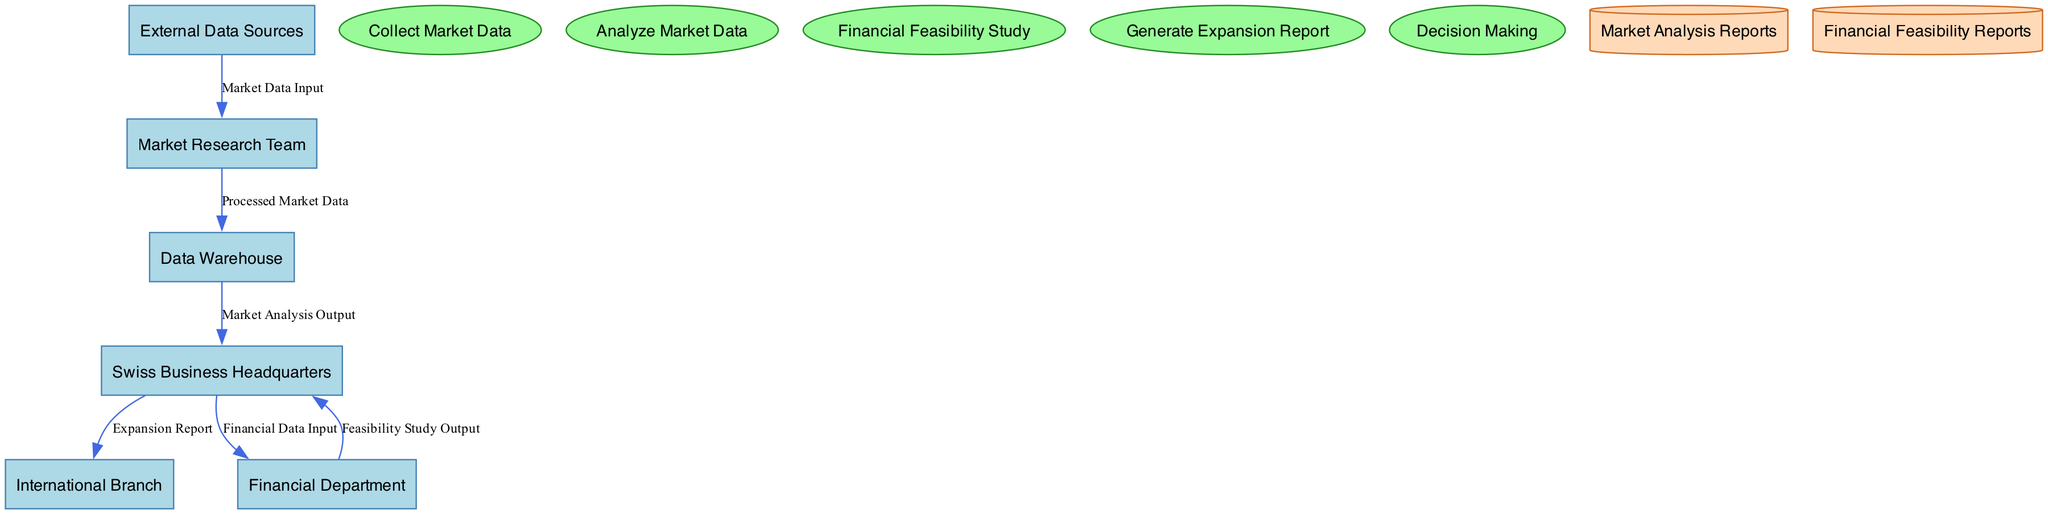What's the number of entities in the diagram? There are six entities listed: Swiss Business Headquarters, Market Research Team, Data Warehouse, International Branch, Financial Department, and External Data Sources. Therefore, the count is 6.
Answer: 6 What is the input for the "Collect Market Data" process? The inputs for the "Collect Market Data" process are "External Data Sources" and "Swiss Business Headquarters." These are the sources from which market data is collected.
Answer: External Data Sources, Swiss Business Headquarters What are the outputs of the "Analyze Market Data" process? The "Analyze Market Data" process outputs analyzed data to the "Swiss Business Headquarters." This is the result of processing the collected market data.
Answer: Swiss Business Headquarters Which entity receives the "Expansion Report"? The "Expansion Report" is sent to two entities: the "Swiss Business Headquarters" and the "International Branch." Both entities receive this report as part of the expansion decision.
Answer: Swiss Business Headquarters, International Branch What type of node is the "Data Warehouse"? The "Data Warehouse" is a data store node, characterized by its shape as a cylinder in the diagram, which differentiates it from processes and entities.
Answer: Data store What is the sequence of processes from market data collection to decision making? The sequence is as follows: "Collect Market Data" → "Analyze Market Data" → "Financial Feasibility Study" → "Generate Expansion Report" → "Decision Making." This sequence shows the flow of processes leading to the final decision.
Answer: Collect Market Data, Analyze Market Data, Financial Feasibility Study, Generate Expansion Report, Decision Making How many data flows are represented in the diagram? There are six data flows depicted in the diagram, connecting the various nodes and showing the direction of data movement.
Answer: 6 What describes the relationship between the "Financial Department" and "Swiss Business Headquarters"? The relationship involves the "Financial Department" receiving financial data inputs from the "Swiss Business Headquarters" and providing feasibility study output back to the same entity. This indicates a feedback loop in their interaction.
Answer: Data exchange 